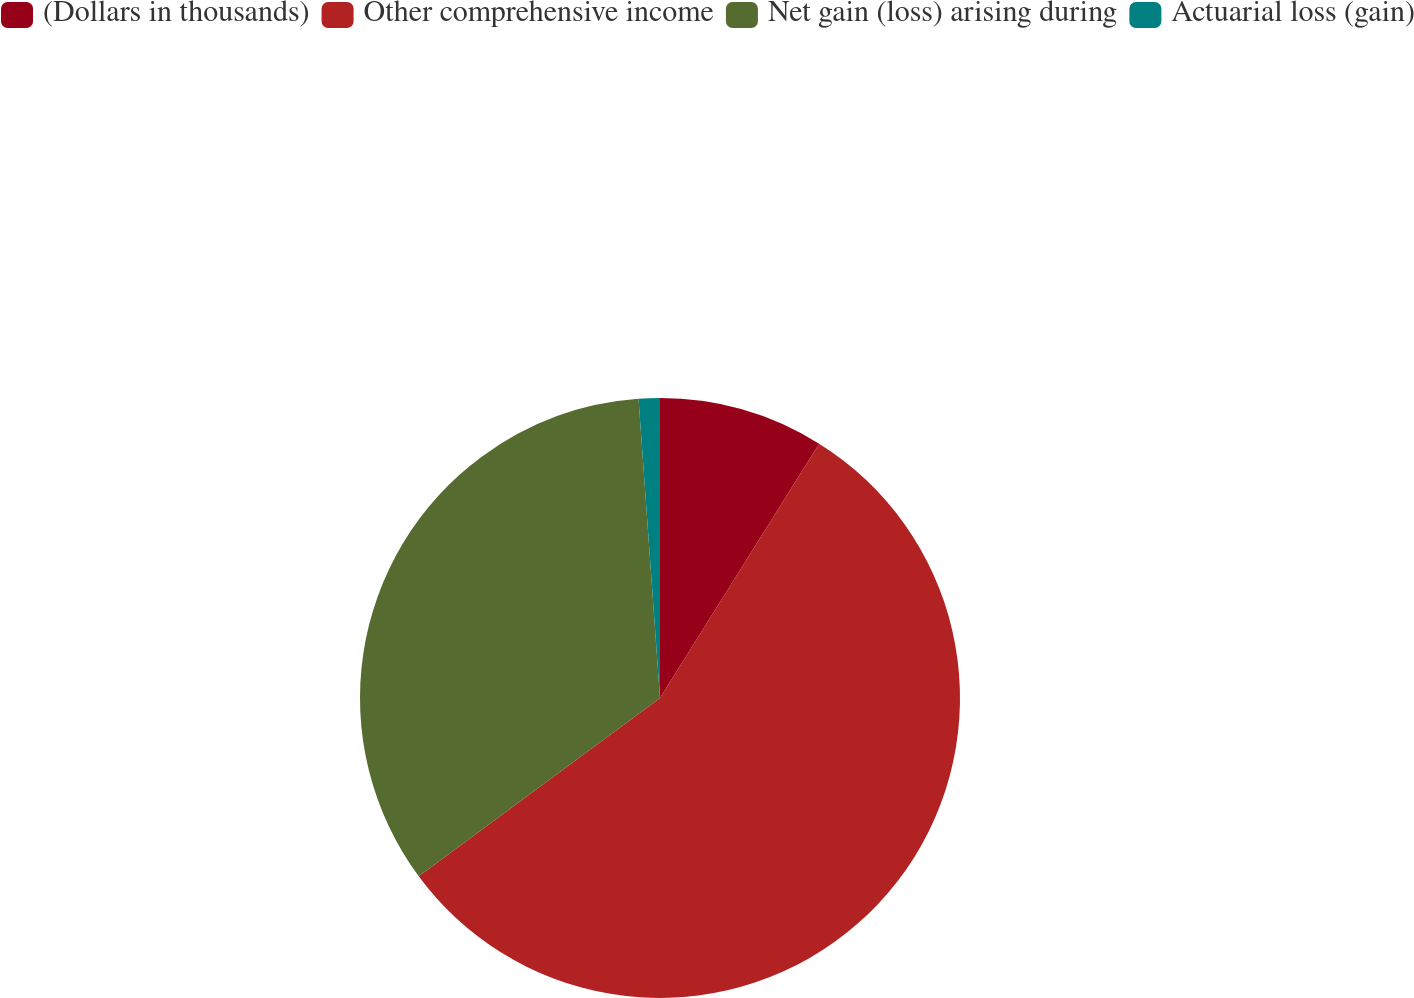Convert chart to OTSL. <chart><loc_0><loc_0><loc_500><loc_500><pie_chart><fcel>(Dollars in thousands)<fcel>Other comprehensive income<fcel>Net gain (loss) arising during<fcel>Actuarial loss (gain)<nl><fcel>8.9%<fcel>55.98%<fcel>33.99%<fcel>1.14%<nl></chart> 